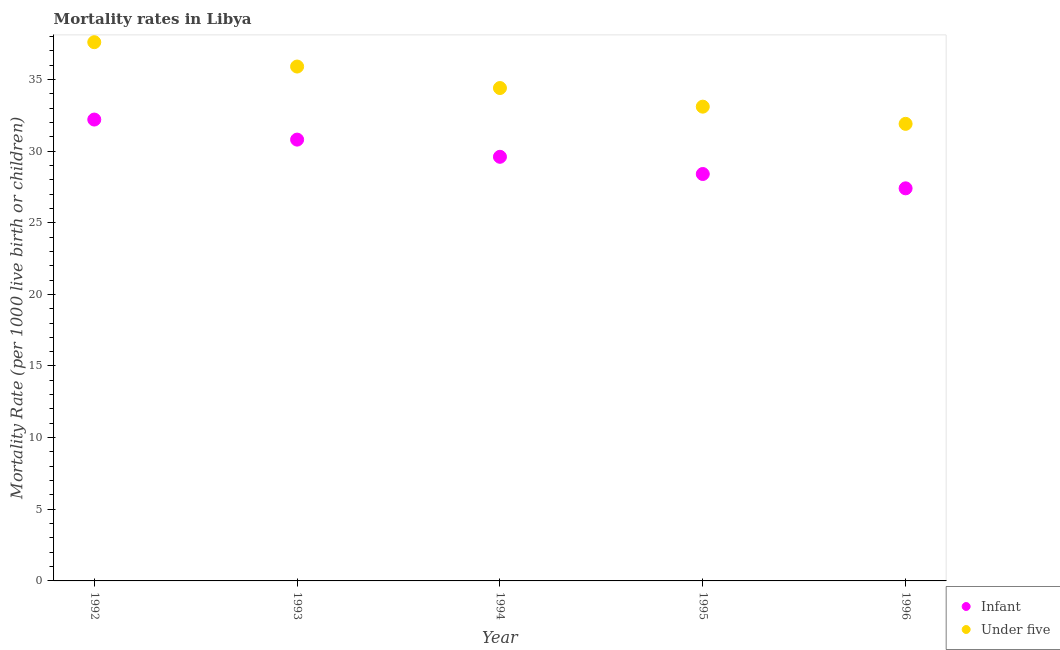How many different coloured dotlines are there?
Your answer should be compact. 2. Is the number of dotlines equal to the number of legend labels?
Give a very brief answer. Yes. What is the infant mortality rate in 1993?
Offer a terse response. 30.8. Across all years, what is the maximum infant mortality rate?
Your answer should be very brief. 32.2. Across all years, what is the minimum under-5 mortality rate?
Provide a short and direct response. 31.9. What is the total under-5 mortality rate in the graph?
Your response must be concise. 172.9. What is the difference between the under-5 mortality rate in 1993 and that in 1994?
Your response must be concise. 1.5. What is the difference between the under-5 mortality rate in 1994 and the infant mortality rate in 1996?
Provide a succinct answer. 7. What is the average under-5 mortality rate per year?
Ensure brevity in your answer.  34.58. In the year 1995, what is the difference between the infant mortality rate and under-5 mortality rate?
Provide a succinct answer. -4.7. What is the ratio of the under-5 mortality rate in 1993 to that in 1995?
Your response must be concise. 1.08. What is the difference between the highest and the second highest infant mortality rate?
Provide a short and direct response. 1.4. What is the difference between the highest and the lowest under-5 mortality rate?
Offer a terse response. 5.7. Is the under-5 mortality rate strictly greater than the infant mortality rate over the years?
Make the answer very short. Yes. How many dotlines are there?
Give a very brief answer. 2. How many years are there in the graph?
Give a very brief answer. 5. Are the values on the major ticks of Y-axis written in scientific E-notation?
Your answer should be compact. No. What is the title of the graph?
Provide a succinct answer. Mortality rates in Libya. Does "Under-five" appear as one of the legend labels in the graph?
Make the answer very short. No. What is the label or title of the X-axis?
Offer a terse response. Year. What is the label or title of the Y-axis?
Make the answer very short. Mortality Rate (per 1000 live birth or children). What is the Mortality Rate (per 1000 live birth or children) of Infant in 1992?
Ensure brevity in your answer.  32.2. What is the Mortality Rate (per 1000 live birth or children) of Under five in 1992?
Offer a terse response. 37.6. What is the Mortality Rate (per 1000 live birth or children) in Infant in 1993?
Your answer should be compact. 30.8. What is the Mortality Rate (per 1000 live birth or children) in Under five in 1993?
Your answer should be very brief. 35.9. What is the Mortality Rate (per 1000 live birth or children) in Infant in 1994?
Provide a succinct answer. 29.6. What is the Mortality Rate (per 1000 live birth or children) of Under five in 1994?
Your answer should be compact. 34.4. What is the Mortality Rate (per 1000 live birth or children) of Infant in 1995?
Provide a succinct answer. 28.4. What is the Mortality Rate (per 1000 live birth or children) in Under five in 1995?
Your answer should be very brief. 33.1. What is the Mortality Rate (per 1000 live birth or children) of Infant in 1996?
Your response must be concise. 27.4. What is the Mortality Rate (per 1000 live birth or children) of Under five in 1996?
Make the answer very short. 31.9. Across all years, what is the maximum Mortality Rate (per 1000 live birth or children) in Infant?
Make the answer very short. 32.2. Across all years, what is the maximum Mortality Rate (per 1000 live birth or children) in Under five?
Keep it short and to the point. 37.6. Across all years, what is the minimum Mortality Rate (per 1000 live birth or children) of Infant?
Offer a very short reply. 27.4. Across all years, what is the minimum Mortality Rate (per 1000 live birth or children) in Under five?
Your answer should be compact. 31.9. What is the total Mortality Rate (per 1000 live birth or children) in Infant in the graph?
Your response must be concise. 148.4. What is the total Mortality Rate (per 1000 live birth or children) in Under five in the graph?
Your answer should be compact. 172.9. What is the difference between the Mortality Rate (per 1000 live birth or children) of Infant in 1992 and that in 1994?
Provide a short and direct response. 2.6. What is the difference between the Mortality Rate (per 1000 live birth or children) of Under five in 1992 and that in 1995?
Keep it short and to the point. 4.5. What is the difference between the Mortality Rate (per 1000 live birth or children) in Infant in 1992 and that in 1996?
Your answer should be compact. 4.8. What is the difference between the Mortality Rate (per 1000 live birth or children) in Under five in 1992 and that in 1996?
Keep it short and to the point. 5.7. What is the difference between the Mortality Rate (per 1000 live birth or children) in Infant in 1993 and that in 1995?
Your response must be concise. 2.4. What is the difference between the Mortality Rate (per 1000 live birth or children) of Under five in 1993 and that in 1995?
Your answer should be very brief. 2.8. What is the difference between the Mortality Rate (per 1000 live birth or children) of Infant in 1993 and that in 1996?
Keep it short and to the point. 3.4. What is the difference between the Mortality Rate (per 1000 live birth or children) in Under five in 1993 and that in 1996?
Keep it short and to the point. 4. What is the difference between the Mortality Rate (per 1000 live birth or children) of Infant in 1994 and that in 1995?
Make the answer very short. 1.2. What is the difference between the Mortality Rate (per 1000 live birth or children) of Under five in 1994 and that in 1995?
Give a very brief answer. 1.3. What is the difference between the Mortality Rate (per 1000 live birth or children) of Infant in 1994 and that in 1996?
Provide a short and direct response. 2.2. What is the difference between the Mortality Rate (per 1000 live birth or children) in Under five in 1994 and that in 1996?
Your response must be concise. 2.5. What is the difference between the Mortality Rate (per 1000 live birth or children) of Infant in 1995 and that in 1996?
Your answer should be very brief. 1. What is the difference between the Mortality Rate (per 1000 live birth or children) of Infant in 1992 and the Mortality Rate (per 1000 live birth or children) of Under five in 1996?
Offer a terse response. 0.3. What is the difference between the Mortality Rate (per 1000 live birth or children) in Infant in 1993 and the Mortality Rate (per 1000 live birth or children) in Under five in 1996?
Offer a terse response. -1.1. What is the average Mortality Rate (per 1000 live birth or children) in Infant per year?
Offer a very short reply. 29.68. What is the average Mortality Rate (per 1000 live birth or children) in Under five per year?
Keep it short and to the point. 34.58. In the year 1993, what is the difference between the Mortality Rate (per 1000 live birth or children) of Infant and Mortality Rate (per 1000 live birth or children) of Under five?
Ensure brevity in your answer.  -5.1. In the year 1994, what is the difference between the Mortality Rate (per 1000 live birth or children) of Infant and Mortality Rate (per 1000 live birth or children) of Under five?
Offer a very short reply. -4.8. In the year 1996, what is the difference between the Mortality Rate (per 1000 live birth or children) in Infant and Mortality Rate (per 1000 live birth or children) in Under five?
Provide a short and direct response. -4.5. What is the ratio of the Mortality Rate (per 1000 live birth or children) of Infant in 1992 to that in 1993?
Your response must be concise. 1.05. What is the ratio of the Mortality Rate (per 1000 live birth or children) of Under five in 1992 to that in 1993?
Give a very brief answer. 1.05. What is the ratio of the Mortality Rate (per 1000 live birth or children) of Infant in 1992 to that in 1994?
Provide a succinct answer. 1.09. What is the ratio of the Mortality Rate (per 1000 live birth or children) of Under five in 1992 to that in 1994?
Keep it short and to the point. 1.09. What is the ratio of the Mortality Rate (per 1000 live birth or children) in Infant in 1992 to that in 1995?
Provide a succinct answer. 1.13. What is the ratio of the Mortality Rate (per 1000 live birth or children) in Under five in 1992 to that in 1995?
Your response must be concise. 1.14. What is the ratio of the Mortality Rate (per 1000 live birth or children) of Infant in 1992 to that in 1996?
Give a very brief answer. 1.18. What is the ratio of the Mortality Rate (per 1000 live birth or children) in Under five in 1992 to that in 1996?
Offer a very short reply. 1.18. What is the ratio of the Mortality Rate (per 1000 live birth or children) in Infant in 1993 to that in 1994?
Your answer should be compact. 1.04. What is the ratio of the Mortality Rate (per 1000 live birth or children) of Under five in 1993 to that in 1994?
Ensure brevity in your answer.  1.04. What is the ratio of the Mortality Rate (per 1000 live birth or children) in Infant in 1993 to that in 1995?
Your answer should be very brief. 1.08. What is the ratio of the Mortality Rate (per 1000 live birth or children) in Under five in 1993 to that in 1995?
Offer a terse response. 1.08. What is the ratio of the Mortality Rate (per 1000 live birth or children) in Infant in 1993 to that in 1996?
Provide a succinct answer. 1.12. What is the ratio of the Mortality Rate (per 1000 live birth or children) in Under five in 1993 to that in 1996?
Give a very brief answer. 1.13. What is the ratio of the Mortality Rate (per 1000 live birth or children) in Infant in 1994 to that in 1995?
Your response must be concise. 1.04. What is the ratio of the Mortality Rate (per 1000 live birth or children) of Under five in 1994 to that in 1995?
Make the answer very short. 1.04. What is the ratio of the Mortality Rate (per 1000 live birth or children) of Infant in 1994 to that in 1996?
Your answer should be very brief. 1.08. What is the ratio of the Mortality Rate (per 1000 live birth or children) in Under five in 1994 to that in 1996?
Give a very brief answer. 1.08. What is the ratio of the Mortality Rate (per 1000 live birth or children) of Infant in 1995 to that in 1996?
Offer a terse response. 1.04. What is the ratio of the Mortality Rate (per 1000 live birth or children) of Under five in 1995 to that in 1996?
Ensure brevity in your answer.  1.04. What is the difference between the highest and the second highest Mortality Rate (per 1000 live birth or children) of Infant?
Provide a short and direct response. 1.4. What is the difference between the highest and the second highest Mortality Rate (per 1000 live birth or children) in Under five?
Keep it short and to the point. 1.7. What is the difference between the highest and the lowest Mortality Rate (per 1000 live birth or children) of Under five?
Your response must be concise. 5.7. 